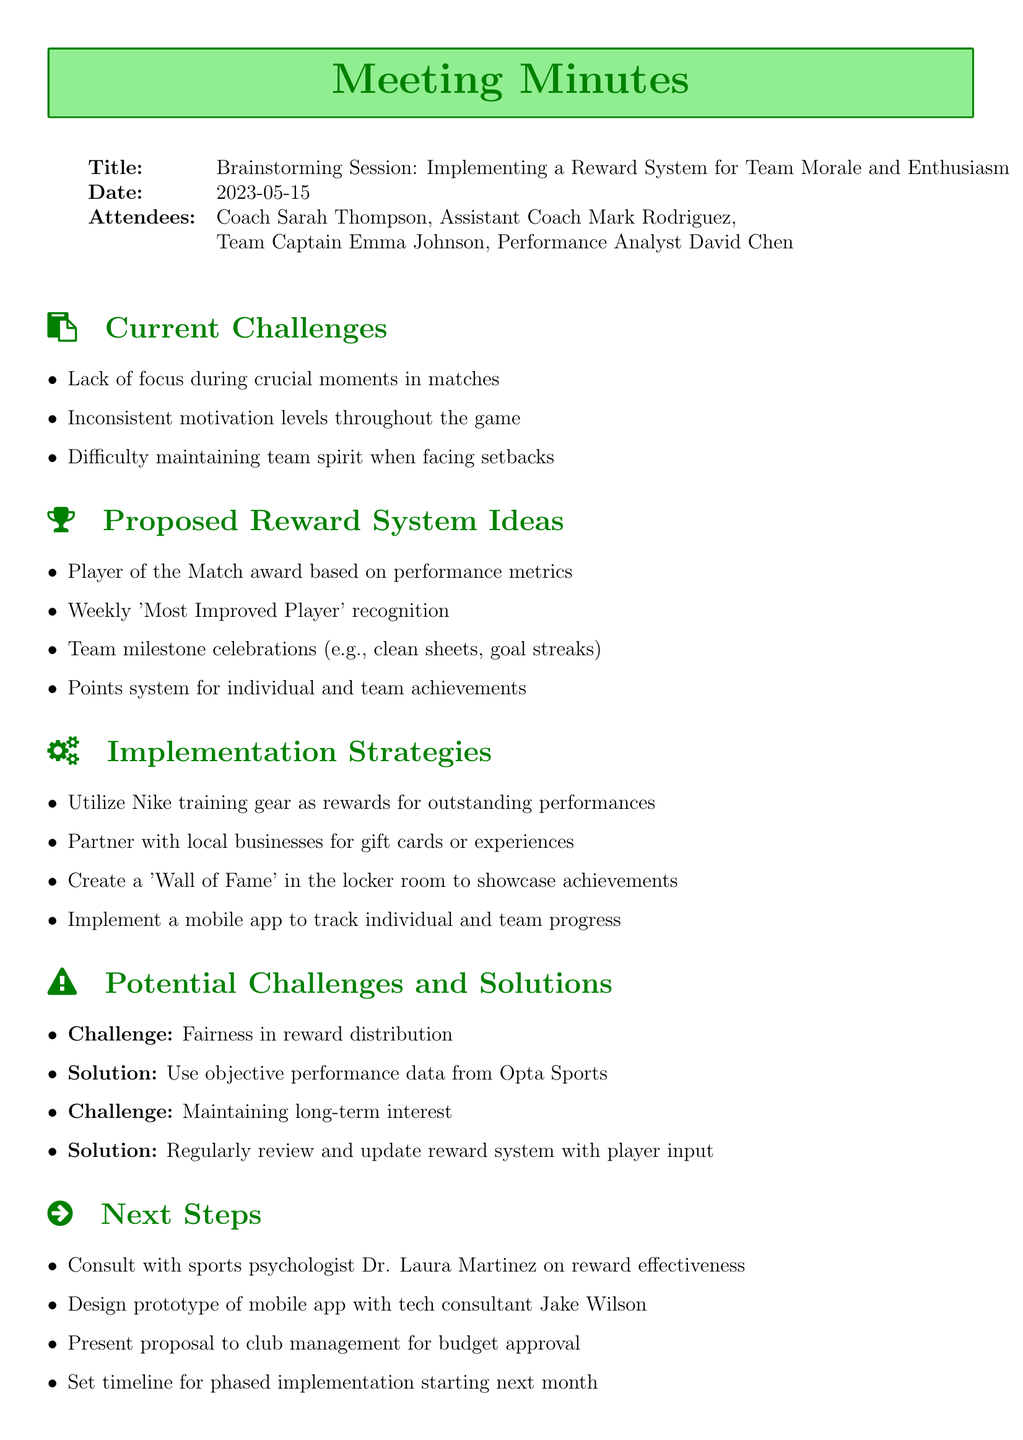What is the title of the meeting? The title of the meeting is mentioned at the top of the document.
Answer: Brainstorming Session: Implementing a Reward System for Team Morale and Enthusiasm What date was the meeting held? The date of the meeting is specified right after the title.
Answer: 2023-05-15 Who is the Team Captain? The name of the Team Captain is listed among the attendees.
Answer: Emma Johnson What is one proposed reward system idea? The proposed reward system ideas are listed under their respective section.
Answer: Player of the Match award based on performance metrics What is the challenge related to reward distribution? The challenges and solutions are enumerated, and one challenge is specified.
Answer: Fairness in reward distribution What implementation strategy involves local businesses? The document lists various implementation strategies, including one that mentions local businesses.
Answer: Partner with local businesses for gift cards or experiences What is one next step after the meeting? The next steps are itemized at the end of the document.
Answer: Consult with sports psychologist Dr. Laura Martinez on reward effectiveness What is the potential challenge related to maintaining interest? The document specifies challenges and their respective solutions, highlighting maintenance of interest.
Answer: Maintaining long-term interest What should be created to showcase achievements? One of the implementation strategies mentions creating something to show the team’s achievements.
Answer: Create a 'Wall of Fame' in the locker room 